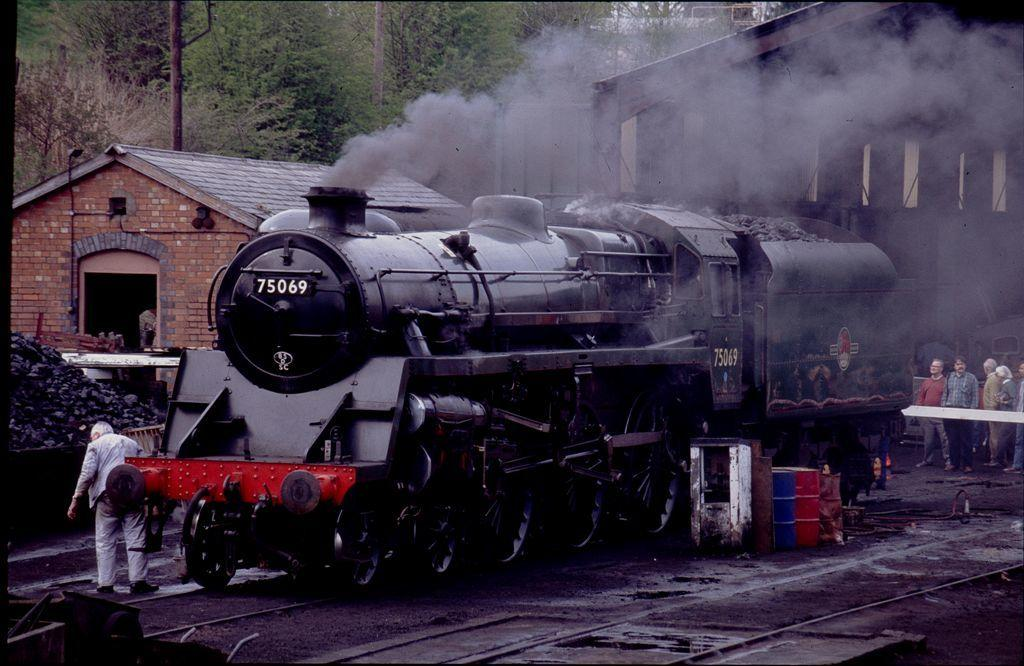What type of vehicle is in the image? There is a steam engine in the image, which is part of a train. Who or what can be seen in the image besides the steam engine? There are people visible in the image. What type of structures are present in the image? There are buildings in the image. What type of natural elements are present in the image? There are trees in the image. What type of beetle can be seen crawling on the steam engine in the image? There is no beetle visible on the steam engine in the image. How does the sleet affect the train's movement in the image? There is no mention of sleet in the image, so its effect on the train's movement cannot be determined. 